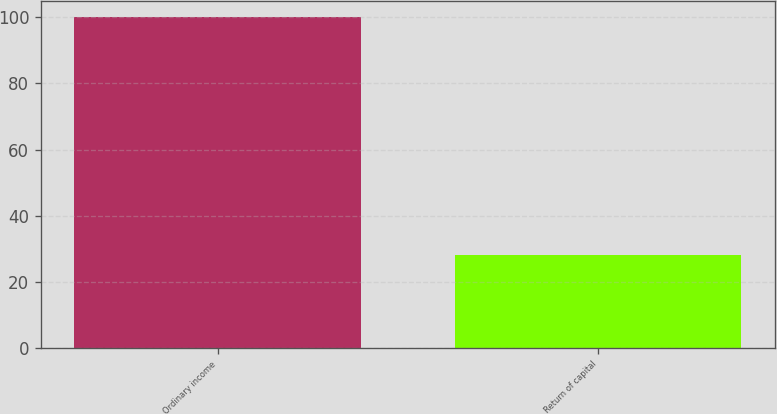<chart> <loc_0><loc_0><loc_500><loc_500><bar_chart><fcel>Ordinary income<fcel>Return of capital<nl><fcel>100<fcel>28<nl></chart> 